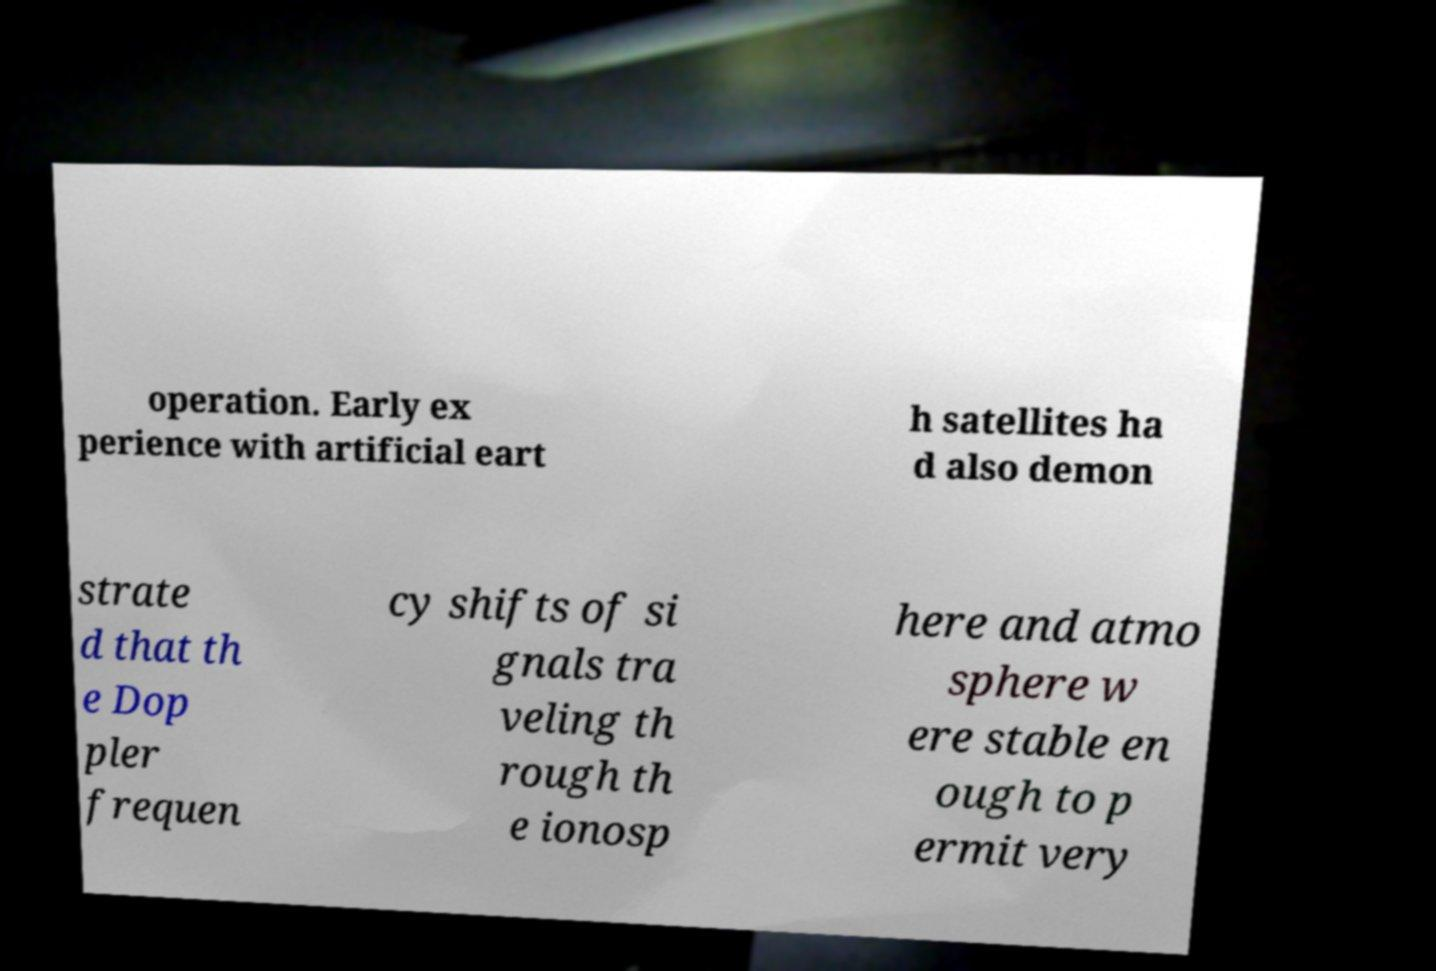Could you extract and type out the text from this image? operation. Early ex perience with artificial eart h satellites ha d also demon strate d that th e Dop pler frequen cy shifts of si gnals tra veling th rough th e ionosp here and atmo sphere w ere stable en ough to p ermit very 